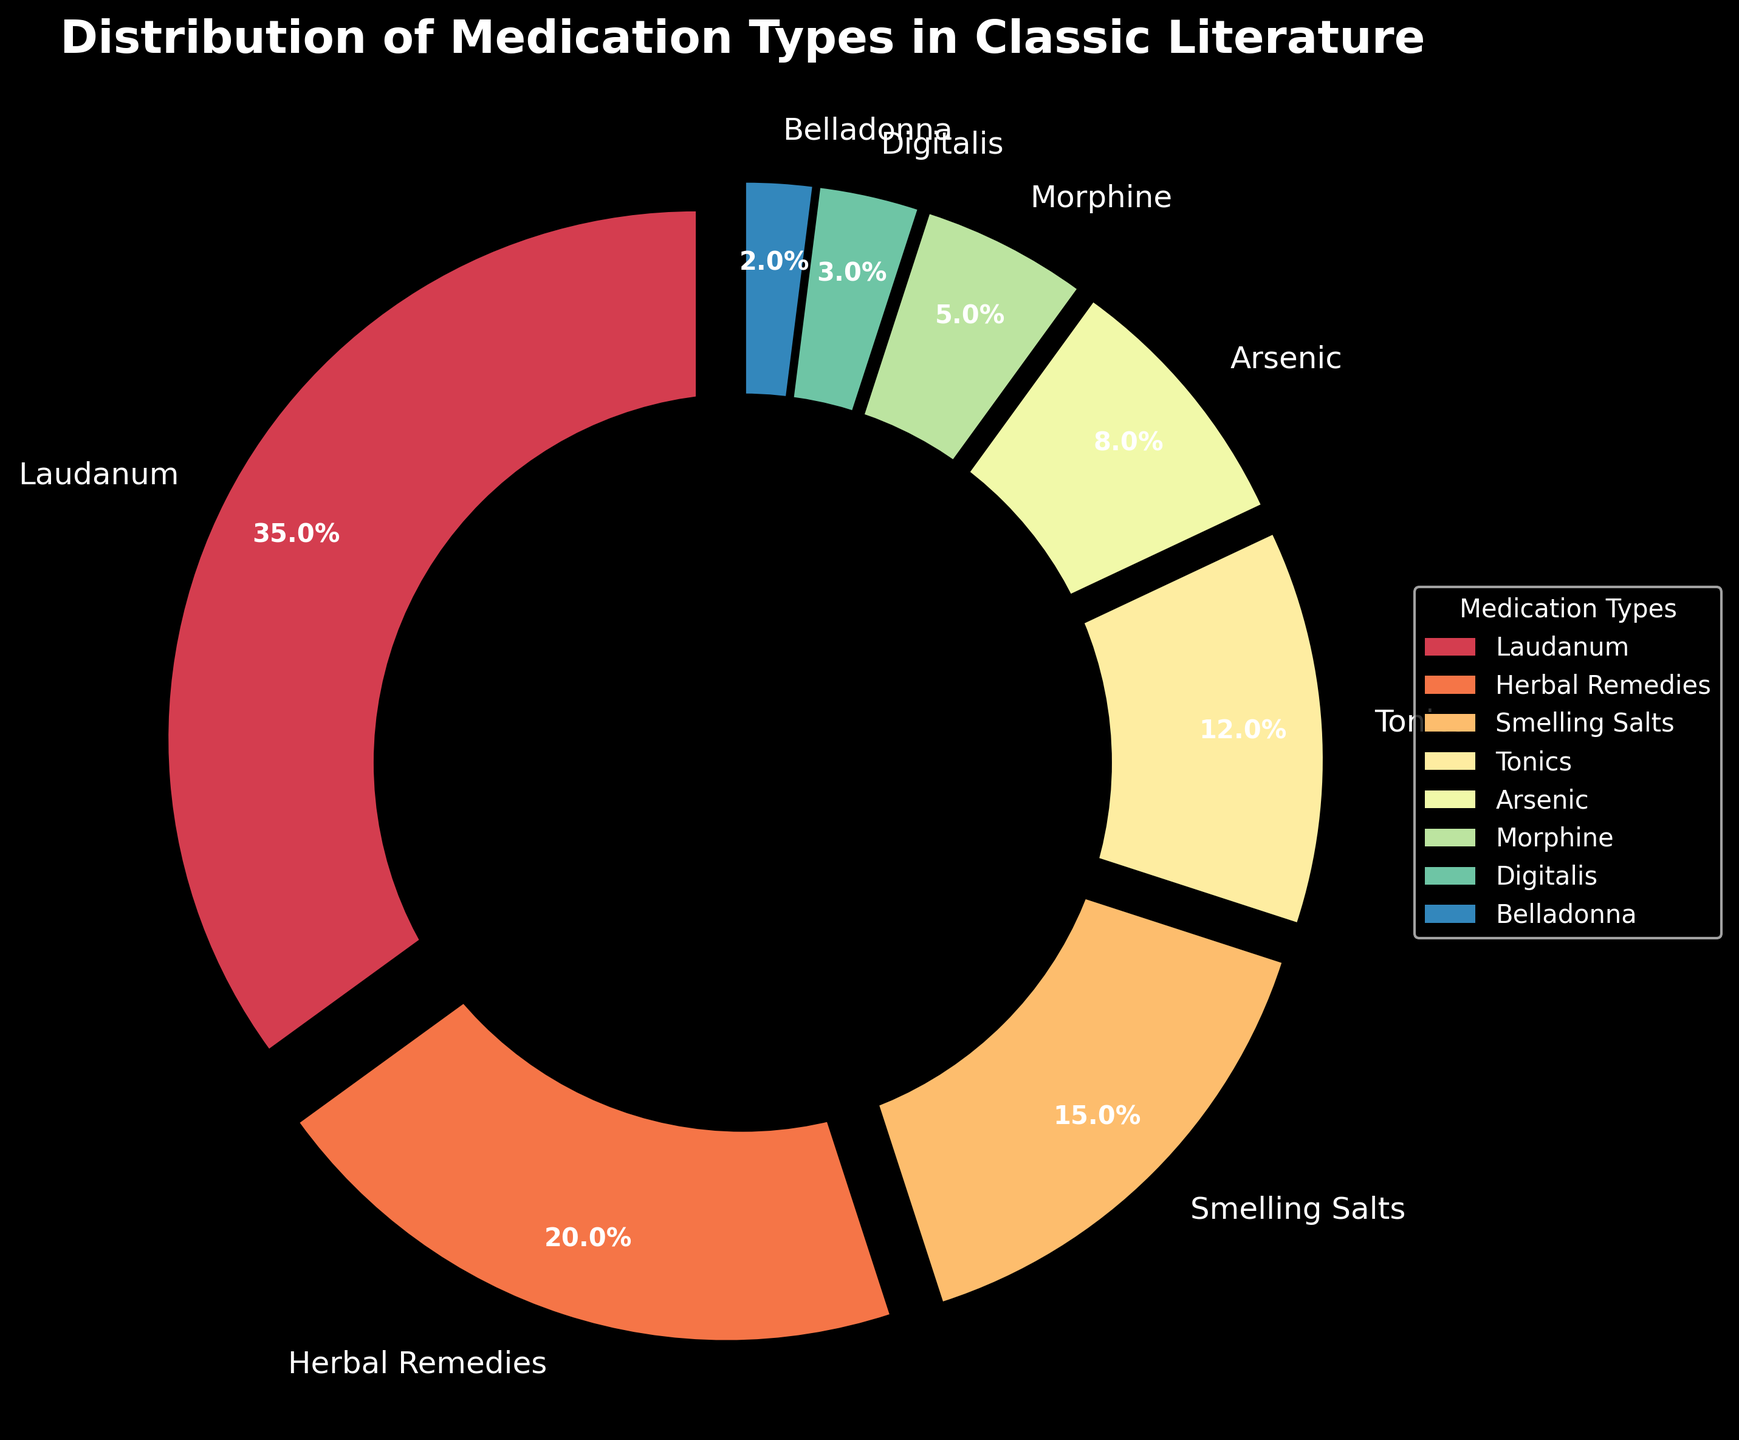What percentage of medication types in classic literature is accounted for by Laudanum and Herbal Remedies combined? Add the percentages of Laudanum (35%) and Herbal Remedies (20%). 35 + 20 = 55
Answer: 55% Which medication type in the plot has the least representation? The medication type with the smallest percentage (2%) is Belladonna.
Answer: Belladonna Are Tonics more or less prevalent than Smelling Salts in the distribution? Tonics have a percentage of 12%, and Smelling Salts have a percentage of 15%. Since 12% is less than 15%, Tonics are less prevalent than Smelling Salts.
Answer: Less What is the sum of the percentages of the four least common medication types? The percentages of the four least common medication types are Belladonna (2%), Digitalis (3%), Morphine (5%), and Arsenic (8%). Adding them together: 2 + 3 + 5 + 8 = 18
Answer: 18% Which segment has the most significant visual prominence based on size, and what is its corresponding medication type? The largest segment visually represents Laudanum, which has the highest percentage at 35%.
Answer: Laudanum Are Herbal Remedies more or less prominent than Arsenic? Herbal Remedies have a percentage of 20%, while Arsenic has a percentage of 8%. Since 20% is more than 8%, Herbal Remedies are more prominent than Arsenic.
Answer: More By how much percentage does Tonics exceed Morphine in the distribution? The percentage of Tonics is 12%, and the percentage of Morphine is 5%. The difference is 12 - 5 = 7%
Answer: 7% What is the color of the section that represents Digitalis in the pie chart? By referring to the legend, the segment representing Digitalis is rendered in a specific color. Checking the color gradient, Digitalis is most likely represented in a cool shade of the spectrum.
Answer: [The answer depends on the specific output of the rendering, typically might be a specific color like "purple".] Which medication types together account for more than half of the distribution? Adding up the percentages of the highest values until the sum exceeds 50%, we get Laudanum (35%) + Herbal Remedies (20%). 35 + 20 = 55%, which is more than half. Laudanum and Herbal Remedies together account for more than half.
Answer: Laudanum and Herbal Remedies 